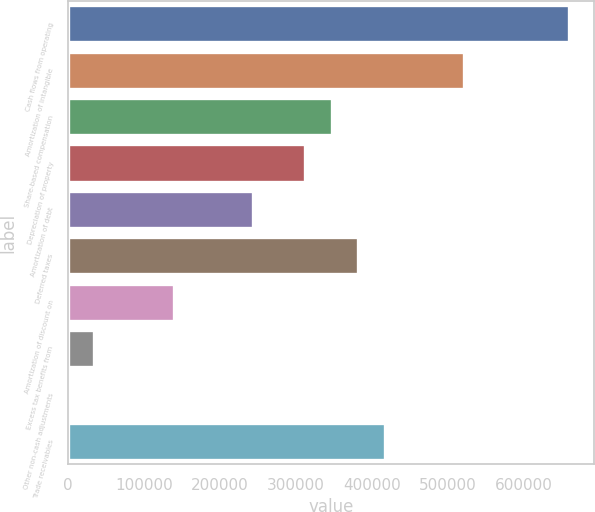<chart> <loc_0><loc_0><loc_500><loc_500><bar_chart><fcel>Cash flows from operating<fcel>Amortization of intangible<fcel>Share-based compensation<fcel>Depreciation of property<fcel>Amortization of debt<fcel>Deferred taxes<fcel>Amortization of discount on<fcel>Excess tax benefits from<fcel>Other non-cash adjustments<fcel>Trade receivables<nl><fcel>659398<fcel>520588<fcel>347075<fcel>312372<fcel>242967<fcel>381778<fcel>138859<fcel>34751.6<fcel>49<fcel>416480<nl></chart> 